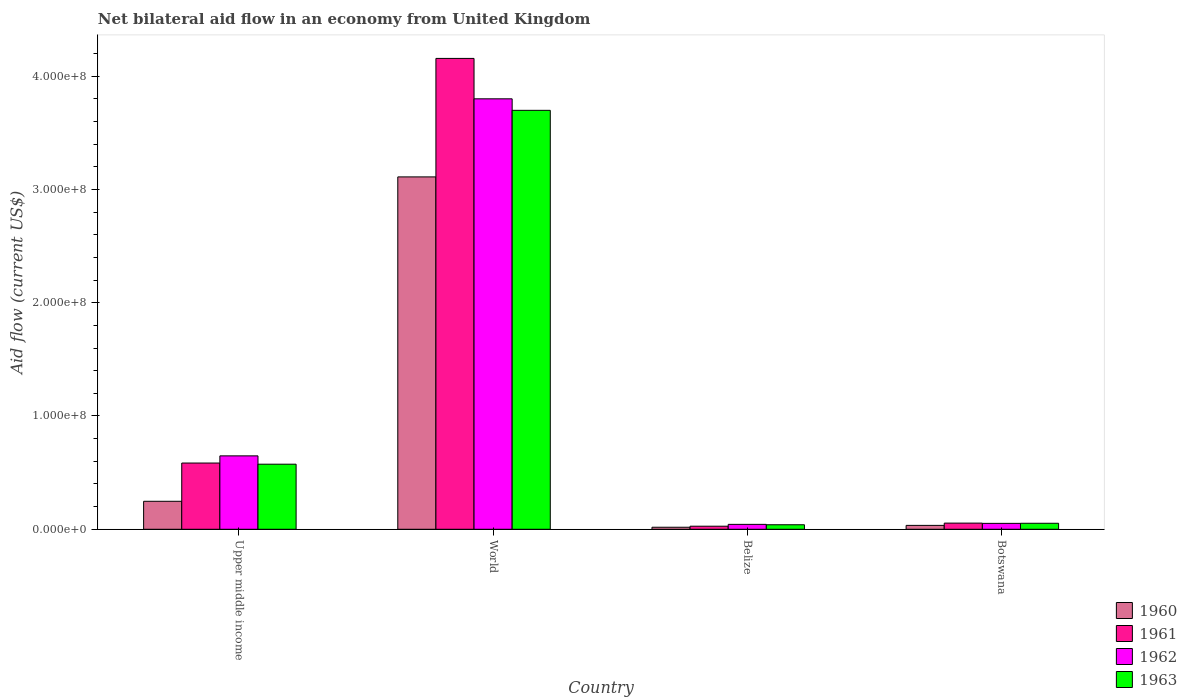How many different coloured bars are there?
Keep it short and to the point. 4. How many groups of bars are there?
Give a very brief answer. 4. How many bars are there on the 3rd tick from the left?
Your response must be concise. 4. How many bars are there on the 2nd tick from the right?
Provide a succinct answer. 4. What is the label of the 2nd group of bars from the left?
Provide a succinct answer. World. What is the net bilateral aid flow in 1962 in World?
Make the answer very short. 3.80e+08. Across all countries, what is the maximum net bilateral aid flow in 1960?
Keep it short and to the point. 3.11e+08. Across all countries, what is the minimum net bilateral aid flow in 1961?
Make the answer very short. 2.70e+06. In which country was the net bilateral aid flow in 1961 maximum?
Give a very brief answer. World. In which country was the net bilateral aid flow in 1962 minimum?
Make the answer very short. Belize. What is the total net bilateral aid flow in 1963 in the graph?
Offer a terse response. 4.37e+08. What is the difference between the net bilateral aid flow in 1960 in Upper middle income and that in World?
Provide a succinct answer. -2.86e+08. What is the difference between the net bilateral aid flow in 1962 in Belize and the net bilateral aid flow in 1963 in Upper middle income?
Keep it short and to the point. -5.31e+07. What is the average net bilateral aid flow in 1963 per country?
Offer a very short reply. 1.09e+08. What is the difference between the net bilateral aid flow of/in 1963 and net bilateral aid flow of/in 1961 in Upper middle income?
Your answer should be compact. -1.02e+06. In how many countries, is the net bilateral aid flow in 1962 greater than 240000000 US$?
Your response must be concise. 1. What is the ratio of the net bilateral aid flow in 1963 in Belize to that in Upper middle income?
Your answer should be compact. 0.07. Is the net bilateral aid flow in 1962 in Belize less than that in World?
Keep it short and to the point. Yes. Is the difference between the net bilateral aid flow in 1963 in Belize and World greater than the difference between the net bilateral aid flow in 1961 in Belize and World?
Offer a very short reply. Yes. What is the difference between the highest and the second highest net bilateral aid flow in 1962?
Your answer should be very brief. 3.15e+08. What is the difference between the highest and the lowest net bilateral aid flow in 1963?
Keep it short and to the point. 3.66e+08. In how many countries, is the net bilateral aid flow in 1961 greater than the average net bilateral aid flow in 1961 taken over all countries?
Give a very brief answer. 1. Is it the case that in every country, the sum of the net bilateral aid flow in 1963 and net bilateral aid flow in 1962 is greater than the sum of net bilateral aid flow in 1961 and net bilateral aid flow in 1960?
Provide a succinct answer. No. What does the 4th bar from the right in World represents?
Offer a terse response. 1960. Is it the case that in every country, the sum of the net bilateral aid flow in 1960 and net bilateral aid flow in 1961 is greater than the net bilateral aid flow in 1963?
Your answer should be compact. Yes. Are all the bars in the graph horizontal?
Your response must be concise. No. Does the graph contain grids?
Give a very brief answer. No. Where does the legend appear in the graph?
Your answer should be compact. Bottom right. How are the legend labels stacked?
Provide a succinct answer. Vertical. What is the title of the graph?
Your answer should be compact. Net bilateral aid flow in an economy from United Kingdom. What is the label or title of the Y-axis?
Your answer should be compact. Aid flow (current US$). What is the Aid flow (current US$) of 1960 in Upper middle income?
Offer a very short reply. 2.47e+07. What is the Aid flow (current US$) of 1961 in Upper middle income?
Your answer should be very brief. 5.85e+07. What is the Aid flow (current US$) of 1962 in Upper middle income?
Your response must be concise. 6.48e+07. What is the Aid flow (current US$) of 1963 in Upper middle income?
Offer a very short reply. 5.74e+07. What is the Aid flow (current US$) in 1960 in World?
Offer a terse response. 3.11e+08. What is the Aid flow (current US$) in 1961 in World?
Give a very brief answer. 4.16e+08. What is the Aid flow (current US$) of 1962 in World?
Make the answer very short. 3.80e+08. What is the Aid flow (current US$) in 1963 in World?
Offer a terse response. 3.70e+08. What is the Aid flow (current US$) of 1960 in Belize?
Make the answer very short. 1.79e+06. What is the Aid flow (current US$) in 1961 in Belize?
Offer a terse response. 2.70e+06. What is the Aid flow (current US$) in 1962 in Belize?
Offer a terse response. 4.33e+06. What is the Aid flow (current US$) of 1963 in Belize?
Offer a very short reply. 3.99e+06. What is the Aid flow (current US$) in 1960 in Botswana?
Offer a very short reply. 3.43e+06. What is the Aid flow (current US$) in 1961 in Botswana?
Provide a short and direct response. 5.44e+06. What is the Aid flow (current US$) in 1962 in Botswana?
Provide a short and direct response. 5.22e+06. What is the Aid flow (current US$) of 1963 in Botswana?
Make the answer very short. 5.30e+06. Across all countries, what is the maximum Aid flow (current US$) in 1960?
Ensure brevity in your answer.  3.11e+08. Across all countries, what is the maximum Aid flow (current US$) in 1961?
Ensure brevity in your answer.  4.16e+08. Across all countries, what is the maximum Aid flow (current US$) in 1962?
Offer a very short reply. 3.80e+08. Across all countries, what is the maximum Aid flow (current US$) of 1963?
Your response must be concise. 3.70e+08. Across all countries, what is the minimum Aid flow (current US$) in 1960?
Provide a succinct answer. 1.79e+06. Across all countries, what is the minimum Aid flow (current US$) in 1961?
Ensure brevity in your answer.  2.70e+06. Across all countries, what is the minimum Aid flow (current US$) of 1962?
Your answer should be compact. 4.33e+06. Across all countries, what is the minimum Aid flow (current US$) of 1963?
Your answer should be very brief. 3.99e+06. What is the total Aid flow (current US$) in 1960 in the graph?
Provide a short and direct response. 3.41e+08. What is the total Aid flow (current US$) in 1961 in the graph?
Provide a succinct answer. 4.82e+08. What is the total Aid flow (current US$) in 1962 in the graph?
Provide a short and direct response. 4.54e+08. What is the total Aid flow (current US$) of 1963 in the graph?
Provide a short and direct response. 4.37e+08. What is the difference between the Aid flow (current US$) of 1960 in Upper middle income and that in World?
Provide a short and direct response. -2.86e+08. What is the difference between the Aid flow (current US$) in 1961 in Upper middle income and that in World?
Your response must be concise. -3.57e+08. What is the difference between the Aid flow (current US$) of 1962 in Upper middle income and that in World?
Give a very brief answer. -3.15e+08. What is the difference between the Aid flow (current US$) of 1963 in Upper middle income and that in World?
Provide a short and direct response. -3.12e+08. What is the difference between the Aid flow (current US$) in 1960 in Upper middle income and that in Belize?
Your answer should be very brief. 2.29e+07. What is the difference between the Aid flow (current US$) in 1961 in Upper middle income and that in Belize?
Your answer should be compact. 5.58e+07. What is the difference between the Aid flow (current US$) in 1962 in Upper middle income and that in Belize?
Ensure brevity in your answer.  6.05e+07. What is the difference between the Aid flow (current US$) of 1963 in Upper middle income and that in Belize?
Your response must be concise. 5.35e+07. What is the difference between the Aid flow (current US$) of 1960 in Upper middle income and that in Botswana?
Your response must be concise. 2.13e+07. What is the difference between the Aid flow (current US$) in 1961 in Upper middle income and that in Botswana?
Provide a succinct answer. 5.30e+07. What is the difference between the Aid flow (current US$) of 1962 in Upper middle income and that in Botswana?
Ensure brevity in your answer.  5.96e+07. What is the difference between the Aid flow (current US$) in 1963 in Upper middle income and that in Botswana?
Your answer should be compact. 5.22e+07. What is the difference between the Aid flow (current US$) of 1960 in World and that in Belize?
Offer a terse response. 3.09e+08. What is the difference between the Aid flow (current US$) of 1961 in World and that in Belize?
Your answer should be very brief. 4.13e+08. What is the difference between the Aid flow (current US$) of 1962 in World and that in Belize?
Provide a short and direct response. 3.76e+08. What is the difference between the Aid flow (current US$) of 1963 in World and that in Belize?
Make the answer very short. 3.66e+08. What is the difference between the Aid flow (current US$) in 1960 in World and that in Botswana?
Ensure brevity in your answer.  3.08e+08. What is the difference between the Aid flow (current US$) of 1961 in World and that in Botswana?
Keep it short and to the point. 4.10e+08. What is the difference between the Aid flow (current US$) of 1962 in World and that in Botswana?
Provide a short and direct response. 3.75e+08. What is the difference between the Aid flow (current US$) of 1963 in World and that in Botswana?
Provide a succinct answer. 3.65e+08. What is the difference between the Aid flow (current US$) of 1960 in Belize and that in Botswana?
Make the answer very short. -1.64e+06. What is the difference between the Aid flow (current US$) of 1961 in Belize and that in Botswana?
Keep it short and to the point. -2.74e+06. What is the difference between the Aid flow (current US$) in 1962 in Belize and that in Botswana?
Your response must be concise. -8.90e+05. What is the difference between the Aid flow (current US$) in 1963 in Belize and that in Botswana?
Your response must be concise. -1.31e+06. What is the difference between the Aid flow (current US$) of 1960 in Upper middle income and the Aid flow (current US$) of 1961 in World?
Your answer should be very brief. -3.91e+08. What is the difference between the Aid flow (current US$) of 1960 in Upper middle income and the Aid flow (current US$) of 1962 in World?
Provide a short and direct response. -3.55e+08. What is the difference between the Aid flow (current US$) of 1960 in Upper middle income and the Aid flow (current US$) of 1963 in World?
Ensure brevity in your answer.  -3.45e+08. What is the difference between the Aid flow (current US$) in 1961 in Upper middle income and the Aid flow (current US$) in 1962 in World?
Keep it short and to the point. -3.22e+08. What is the difference between the Aid flow (current US$) in 1961 in Upper middle income and the Aid flow (current US$) in 1963 in World?
Your response must be concise. -3.11e+08. What is the difference between the Aid flow (current US$) in 1962 in Upper middle income and the Aid flow (current US$) in 1963 in World?
Provide a short and direct response. -3.05e+08. What is the difference between the Aid flow (current US$) in 1960 in Upper middle income and the Aid flow (current US$) in 1961 in Belize?
Offer a terse response. 2.20e+07. What is the difference between the Aid flow (current US$) in 1960 in Upper middle income and the Aid flow (current US$) in 1962 in Belize?
Offer a terse response. 2.04e+07. What is the difference between the Aid flow (current US$) in 1960 in Upper middle income and the Aid flow (current US$) in 1963 in Belize?
Offer a terse response. 2.07e+07. What is the difference between the Aid flow (current US$) of 1961 in Upper middle income and the Aid flow (current US$) of 1962 in Belize?
Provide a succinct answer. 5.41e+07. What is the difference between the Aid flow (current US$) of 1961 in Upper middle income and the Aid flow (current US$) of 1963 in Belize?
Your answer should be compact. 5.45e+07. What is the difference between the Aid flow (current US$) in 1962 in Upper middle income and the Aid flow (current US$) in 1963 in Belize?
Offer a terse response. 6.08e+07. What is the difference between the Aid flow (current US$) in 1960 in Upper middle income and the Aid flow (current US$) in 1961 in Botswana?
Your answer should be compact. 1.93e+07. What is the difference between the Aid flow (current US$) in 1960 in Upper middle income and the Aid flow (current US$) in 1962 in Botswana?
Provide a succinct answer. 1.95e+07. What is the difference between the Aid flow (current US$) of 1960 in Upper middle income and the Aid flow (current US$) of 1963 in Botswana?
Ensure brevity in your answer.  1.94e+07. What is the difference between the Aid flow (current US$) of 1961 in Upper middle income and the Aid flow (current US$) of 1962 in Botswana?
Give a very brief answer. 5.32e+07. What is the difference between the Aid flow (current US$) in 1961 in Upper middle income and the Aid flow (current US$) in 1963 in Botswana?
Ensure brevity in your answer.  5.32e+07. What is the difference between the Aid flow (current US$) in 1962 in Upper middle income and the Aid flow (current US$) in 1963 in Botswana?
Provide a short and direct response. 5.95e+07. What is the difference between the Aid flow (current US$) of 1960 in World and the Aid flow (current US$) of 1961 in Belize?
Offer a very short reply. 3.08e+08. What is the difference between the Aid flow (current US$) in 1960 in World and the Aid flow (current US$) in 1962 in Belize?
Keep it short and to the point. 3.07e+08. What is the difference between the Aid flow (current US$) of 1960 in World and the Aid flow (current US$) of 1963 in Belize?
Your answer should be very brief. 3.07e+08. What is the difference between the Aid flow (current US$) of 1961 in World and the Aid flow (current US$) of 1962 in Belize?
Offer a very short reply. 4.11e+08. What is the difference between the Aid flow (current US$) of 1961 in World and the Aid flow (current US$) of 1963 in Belize?
Provide a short and direct response. 4.12e+08. What is the difference between the Aid flow (current US$) in 1962 in World and the Aid flow (current US$) in 1963 in Belize?
Provide a short and direct response. 3.76e+08. What is the difference between the Aid flow (current US$) of 1960 in World and the Aid flow (current US$) of 1961 in Botswana?
Offer a very short reply. 3.06e+08. What is the difference between the Aid flow (current US$) of 1960 in World and the Aid flow (current US$) of 1962 in Botswana?
Offer a terse response. 3.06e+08. What is the difference between the Aid flow (current US$) of 1960 in World and the Aid flow (current US$) of 1963 in Botswana?
Your response must be concise. 3.06e+08. What is the difference between the Aid flow (current US$) of 1961 in World and the Aid flow (current US$) of 1962 in Botswana?
Your response must be concise. 4.10e+08. What is the difference between the Aid flow (current US$) in 1961 in World and the Aid flow (current US$) in 1963 in Botswana?
Keep it short and to the point. 4.10e+08. What is the difference between the Aid flow (current US$) in 1962 in World and the Aid flow (current US$) in 1963 in Botswana?
Ensure brevity in your answer.  3.75e+08. What is the difference between the Aid flow (current US$) in 1960 in Belize and the Aid flow (current US$) in 1961 in Botswana?
Your answer should be compact. -3.65e+06. What is the difference between the Aid flow (current US$) in 1960 in Belize and the Aid flow (current US$) in 1962 in Botswana?
Your response must be concise. -3.43e+06. What is the difference between the Aid flow (current US$) of 1960 in Belize and the Aid flow (current US$) of 1963 in Botswana?
Your answer should be compact. -3.51e+06. What is the difference between the Aid flow (current US$) of 1961 in Belize and the Aid flow (current US$) of 1962 in Botswana?
Offer a terse response. -2.52e+06. What is the difference between the Aid flow (current US$) of 1961 in Belize and the Aid flow (current US$) of 1963 in Botswana?
Make the answer very short. -2.60e+06. What is the difference between the Aid flow (current US$) in 1962 in Belize and the Aid flow (current US$) in 1963 in Botswana?
Provide a succinct answer. -9.70e+05. What is the average Aid flow (current US$) of 1960 per country?
Keep it short and to the point. 8.52e+07. What is the average Aid flow (current US$) of 1961 per country?
Ensure brevity in your answer.  1.21e+08. What is the average Aid flow (current US$) in 1962 per country?
Offer a very short reply. 1.14e+08. What is the average Aid flow (current US$) in 1963 per country?
Your answer should be very brief. 1.09e+08. What is the difference between the Aid flow (current US$) of 1960 and Aid flow (current US$) of 1961 in Upper middle income?
Your answer should be compact. -3.38e+07. What is the difference between the Aid flow (current US$) in 1960 and Aid flow (current US$) in 1962 in Upper middle income?
Your answer should be compact. -4.01e+07. What is the difference between the Aid flow (current US$) in 1960 and Aid flow (current US$) in 1963 in Upper middle income?
Ensure brevity in your answer.  -3.28e+07. What is the difference between the Aid flow (current US$) of 1961 and Aid flow (current US$) of 1962 in Upper middle income?
Provide a short and direct response. -6.33e+06. What is the difference between the Aid flow (current US$) in 1961 and Aid flow (current US$) in 1963 in Upper middle income?
Your answer should be compact. 1.02e+06. What is the difference between the Aid flow (current US$) of 1962 and Aid flow (current US$) of 1963 in Upper middle income?
Keep it short and to the point. 7.35e+06. What is the difference between the Aid flow (current US$) of 1960 and Aid flow (current US$) of 1961 in World?
Provide a succinct answer. -1.05e+08. What is the difference between the Aid flow (current US$) of 1960 and Aid flow (current US$) of 1962 in World?
Offer a terse response. -6.89e+07. What is the difference between the Aid flow (current US$) of 1960 and Aid flow (current US$) of 1963 in World?
Ensure brevity in your answer.  -5.88e+07. What is the difference between the Aid flow (current US$) in 1961 and Aid flow (current US$) in 1962 in World?
Ensure brevity in your answer.  3.57e+07. What is the difference between the Aid flow (current US$) in 1961 and Aid flow (current US$) in 1963 in World?
Your answer should be very brief. 4.58e+07. What is the difference between the Aid flow (current US$) of 1962 and Aid flow (current US$) of 1963 in World?
Keep it short and to the point. 1.02e+07. What is the difference between the Aid flow (current US$) in 1960 and Aid flow (current US$) in 1961 in Belize?
Provide a short and direct response. -9.10e+05. What is the difference between the Aid flow (current US$) in 1960 and Aid flow (current US$) in 1962 in Belize?
Give a very brief answer. -2.54e+06. What is the difference between the Aid flow (current US$) in 1960 and Aid flow (current US$) in 1963 in Belize?
Offer a terse response. -2.20e+06. What is the difference between the Aid flow (current US$) in 1961 and Aid flow (current US$) in 1962 in Belize?
Your answer should be very brief. -1.63e+06. What is the difference between the Aid flow (current US$) of 1961 and Aid flow (current US$) of 1963 in Belize?
Make the answer very short. -1.29e+06. What is the difference between the Aid flow (current US$) in 1962 and Aid flow (current US$) in 1963 in Belize?
Keep it short and to the point. 3.40e+05. What is the difference between the Aid flow (current US$) in 1960 and Aid flow (current US$) in 1961 in Botswana?
Offer a terse response. -2.01e+06. What is the difference between the Aid flow (current US$) of 1960 and Aid flow (current US$) of 1962 in Botswana?
Keep it short and to the point. -1.79e+06. What is the difference between the Aid flow (current US$) of 1960 and Aid flow (current US$) of 1963 in Botswana?
Provide a short and direct response. -1.87e+06. What is the difference between the Aid flow (current US$) in 1962 and Aid flow (current US$) in 1963 in Botswana?
Keep it short and to the point. -8.00e+04. What is the ratio of the Aid flow (current US$) of 1960 in Upper middle income to that in World?
Provide a short and direct response. 0.08. What is the ratio of the Aid flow (current US$) of 1961 in Upper middle income to that in World?
Your answer should be very brief. 0.14. What is the ratio of the Aid flow (current US$) in 1962 in Upper middle income to that in World?
Your answer should be compact. 0.17. What is the ratio of the Aid flow (current US$) in 1963 in Upper middle income to that in World?
Your response must be concise. 0.16. What is the ratio of the Aid flow (current US$) of 1960 in Upper middle income to that in Belize?
Provide a short and direct response. 13.8. What is the ratio of the Aid flow (current US$) in 1961 in Upper middle income to that in Belize?
Give a very brief answer. 21.66. What is the ratio of the Aid flow (current US$) in 1962 in Upper middle income to that in Belize?
Provide a succinct answer. 14.97. What is the ratio of the Aid flow (current US$) in 1963 in Upper middle income to that in Belize?
Give a very brief answer. 14.4. What is the ratio of the Aid flow (current US$) in 1960 in Upper middle income to that in Botswana?
Provide a succinct answer. 7.2. What is the ratio of the Aid flow (current US$) of 1961 in Upper middle income to that in Botswana?
Keep it short and to the point. 10.75. What is the ratio of the Aid flow (current US$) in 1962 in Upper middle income to that in Botswana?
Provide a succinct answer. 12.41. What is the ratio of the Aid flow (current US$) in 1963 in Upper middle income to that in Botswana?
Offer a very short reply. 10.84. What is the ratio of the Aid flow (current US$) of 1960 in World to that in Belize?
Offer a terse response. 173.77. What is the ratio of the Aid flow (current US$) in 1961 in World to that in Belize?
Provide a succinct answer. 153.94. What is the ratio of the Aid flow (current US$) of 1962 in World to that in Belize?
Provide a short and direct response. 87.75. What is the ratio of the Aid flow (current US$) in 1963 in World to that in Belize?
Offer a terse response. 92.68. What is the ratio of the Aid flow (current US$) of 1960 in World to that in Botswana?
Provide a short and direct response. 90.69. What is the ratio of the Aid flow (current US$) in 1961 in World to that in Botswana?
Offer a terse response. 76.4. What is the ratio of the Aid flow (current US$) of 1962 in World to that in Botswana?
Provide a short and direct response. 72.79. What is the ratio of the Aid flow (current US$) of 1963 in World to that in Botswana?
Your answer should be compact. 69.78. What is the ratio of the Aid flow (current US$) in 1960 in Belize to that in Botswana?
Make the answer very short. 0.52. What is the ratio of the Aid flow (current US$) of 1961 in Belize to that in Botswana?
Your answer should be very brief. 0.5. What is the ratio of the Aid flow (current US$) in 1962 in Belize to that in Botswana?
Offer a terse response. 0.83. What is the ratio of the Aid flow (current US$) of 1963 in Belize to that in Botswana?
Offer a terse response. 0.75. What is the difference between the highest and the second highest Aid flow (current US$) in 1960?
Provide a succinct answer. 2.86e+08. What is the difference between the highest and the second highest Aid flow (current US$) in 1961?
Give a very brief answer. 3.57e+08. What is the difference between the highest and the second highest Aid flow (current US$) of 1962?
Provide a short and direct response. 3.15e+08. What is the difference between the highest and the second highest Aid flow (current US$) in 1963?
Give a very brief answer. 3.12e+08. What is the difference between the highest and the lowest Aid flow (current US$) of 1960?
Your answer should be compact. 3.09e+08. What is the difference between the highest and the lowest Aid flow (current US$) of 1961?
Give a very brief answer. 4.13e+08. What is the difference between the highest and the lowest Aid flow (current US$) of 1962?
Provide a succinct answer. 3.76e+08. What is the difference between the highest and the lowest Aid flow (current US$) of 1963?
Offer a terse response. 3.66e+08. 